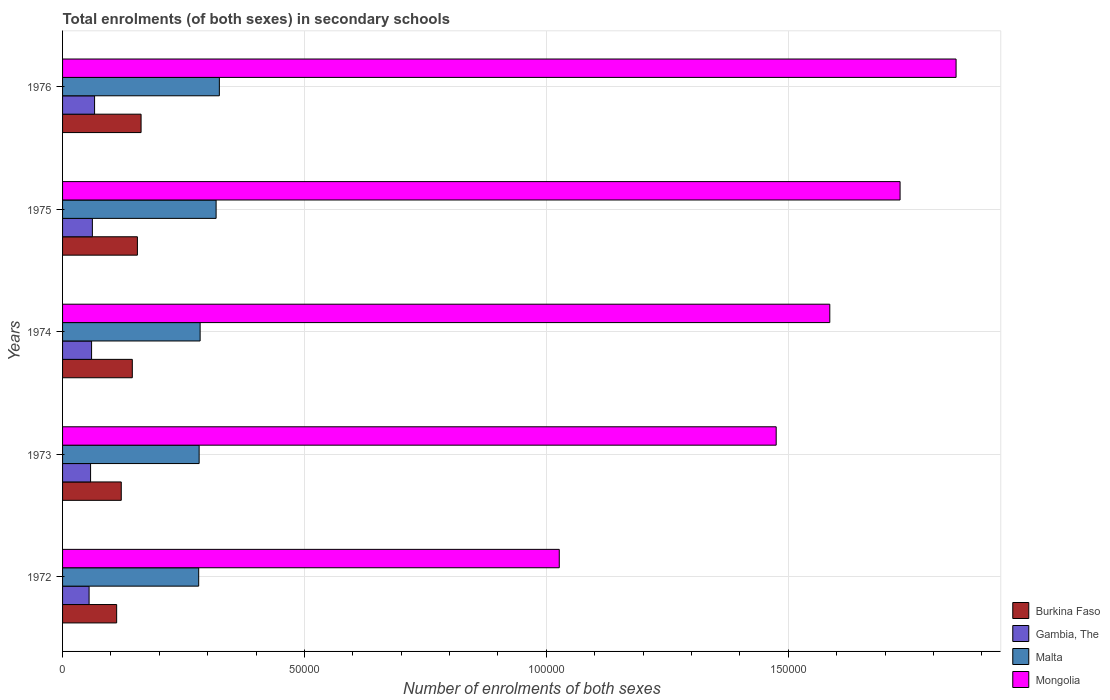How many different coloured bars are there?
Provide a succinct answer. 4. How many groups of bars are there?
Offer a very short reply. 5. Are the number of bars per tick equal to the number of legend labels?
Your answer should be very brief. Yes. How many bars are there on the 1st tick from the top?
Give a very brief answer. 4. What is the label of the 3rd group of bars from the top?
Make the answer very short. 1974. In how many cases, is the number of bars for a given year not equal to the number of legend labels?
Provide a succinct answer. 0. What is the number of enrolments in secondary schools in Malta in 1973?
Provide a succinct answer. 2.82e+04. Across all years, what is the maximum number of enrolments in secondary schools in Gambia, The?
Your response must be concise. 6618. Across all years, what is the minimum number of enrolments in secondary schools in Burkina Faso?
Offer a very short reply. 1.12e+04. In which year was the number of enrolments in secondary schools in Mongolia maximum?
Provide a succinct answer. 1976. In which year was the number of enrolments in secondary schools in Malta minimum?
Provide a succinct answer. 1972. What is the total number of enrolments in secondary schools in Malta in the graph?
Your answer should be very brief. 1.49e+05. What is the difference between the number of enrolments in secondary schools in Gambia, The in 1974 and that in 1975?
Provide a succinct answer. -165. What is the difference between the number of enrolments in secondary schools in Gambia, The in 1975 and the number of enrolments in secondary schools in Burkina Faso in 1972?
Give a very brief answer. -5017. What is the average number of enrolments in secondary schools in Gambia, The per year?
Provide a succinct answer. 6010. In the year 1973, what is the difference between the number of enrolments in secondary schools in Malta and number of enrolments in secondary schools in Mongolia?
Offer a very short reply. -1.19e+05. In how many years, is the number of enrolments in secondary schools in Mongolia greater than 170000 ?
Your response must be concise. 2. What is the ratio of the number of enrolments in secondary schools in Malta in 1972 to that in 1975?
Make the answer very short. 0.89. Is the difference between the number of enrolments in secondary schools in Malta in 1972 and 1973 greater than the difference between the number of enrolments in secondary schools in Mongolia in 1972 and 1973?
Ensure brevity in your answer.  Yes. What is the difference between the highest and the second highest number of enrolments in secondary schools in Malta?
Your answer should be very brief. 673. What is the difference between the highest and the lowest number of enrolments in secondary schools in Burkina Faso?
Ensure brevity in your answer.  5048. In how many years, is the number of enrolments in secondary schools in Burkina Faso greater than the average number of enrolments in secondary schools in Burkina Faso taken over all years?
Provide a succinct answer. 3. What does the 2nd bar from the top in 1973 represents?
Offer a terse response. Malta. What does the 2nd bar from the bottom in 1973 represents?
Provide a succinct answer. Gambia, The. How many bars are there?
Your answer should be very brief. 20. Are all the bars in the graph horizontal?
Your answer should be very brief. Yes. Are the values on the major ticks of X-axis written in scientific E-notation?
Offer a terse response. No. Does the graph contain any zero values?
Make the answer very short. No. How many legend labels are there?
Provide a short and direct response. 4. How are the legend labels stacked?
Give a very brief answer. Vertical. What is the title of the graph?
Offer a very short reply. Total enrolments (of both sexes) in secondary schools. Does "Solomon Islands" appear as one of the legend labels in the graph?
Offer a very short reply. No. What is the label or title of the X-axis?
Provide a short and direct response. Number of enrolments of both sexes. What is the label or title of the Y-axis?
Make the answer very short. Years. What is the Number of enrolments of both sexes of Burkina Faso in 1972?
Offer a very short reply. 1.12e+04. What is the Number of enrolments of both sexes in Gambia, The in 1972?
Give a very brief answer. 5482. What is the Number of enrolments of both sexes of Malta in 1972?
Keep it short and to the point. 2.81e+04. What is the Number of enrolments of both sexes of Mongolia in 1972?
Provide a succinct answer. 1.03e+05. What is the Number of enrolments of both sexes of Burkina Faso in 1973?
Offer a very short reply. 1.21e+04. What is the Number of enrolments of both sexes in Gambia, The in 1973?
Provide a succinct answer. 5791. What is the Number of enrolments of both sexes in Malta in 1973?
Your answer should be compact. 2.82e+04. What is the Number of enrolments of both sexes in Mongolia in 1973?
Your answer should be compact. 1.48e+05. What is the Number of enrolments of both sexes of Burkina Faso in 1974?
Keep it short and to the point. 1.44e+04. What is the Number of enrolments of both sexes in Gambia, The in 1974?
Keep it short and to the point. 5997. What is the Number of enrolments of both sexes in Malta in 1974?
Offer a very short reply. 2.84e+04. What is the Number of enrolments of both sexes of Mongolia in 1974?
Your answer should be very brief. 1.59e+05. What is the Number of enrolments of both sexes of Burkina Faso in 1975?
Provide a short and direct response. 1.55e+04. What is the Number of enrolments of both sexes in Gambia, The in 1975?
Your answer should be very brief. 6162. What is the Number of enrolments of both sexes of Malta in 1975?
Keep it short and to the point. 3.17e+04. What is the Number of enrolments of both sexes of Mongolia in 1975?
Your answer should be compact. 1.73e+05. What is the Number of enrolments of both sexes of Burkina Faso in 1976?
Provide a short and direct response. 1.62e+04. What is the Number of enrolments of both sexes in Gambia, The in 1976?
Make the answer very short. 6618. What is the Number of enrolments of both sexes of Malta in 1976?
Give a very brief answer. 3.24e+04. What is the Number of enrolments of both sexes of Mongolia in 1976?
Offer a terse response. 1.85e+05. Across all years, what is the maximum Number of enrolments of both sexes of Burkina Faso?
Your response must be concise. 1.62e+04. Across all years, what is the maximum Number of enrolments of both sexes of Gambia, The?
Your response must be concise. 6618. Across all years, what is the maximum Number of enrolments of both sexes of Malta?
Ensure brevity in your answer.  3.24e+04. Across all years, what is the maximum Number of enrolments of both sexes of Mongolia?
Keep it short and to the point. 1.85e+05. Across all years, what is the minimum Number of enrolments of both sexes of Burkina Faso?
Offer a very short reply. 1.12e+04. Across all years, what is the minimum Number of enrolments of both sexes in Gambia, The?
Ensure brevity in your answer.  5482. Across all years, what is the minimum Number of enrolments of both sexes of Malta?
Provide a succinct answer. 2.81e+04. Across all years, what is the minimum Number of enrolments of both sexes of Mongolia?
Your answer should be very brief. 1.03e+05. What is the total Number of enrolments of both sexes of Burkina Faso in the graph?
Provide a succinct answer. 6.94e+04. What is the total Number of enrolments of both sexes of Gambia, The in the graph?
Make the answer very short. 3.00e+04. What is the total Number of enrolments of both sexes in Malta in the graph?
Your answer should be compact. 1.49e+05. What is the total Number of enrolments of both sexes of Mongolia in the graph?
Provide a succinct answer. 7.67e+05. What is the difference between the Number of enrolments of both sexes of Burkina Faso in 1972 and that in 1973?
Your answer should be very brief. -953. What is the difference between the Number of enrolments of both sexes of Gambia, The in 1972 and that in 1973?
Keep it short and to the point. -309. What is the difference between the Number of enrolments of both sexes in Malta in 1972 and that in 1973?
Ensure brevity in your answer.  -94. What is the difference between the Number of enrolments of both sexes of Mongolia in 1972 and that in 1973?
Provide a succinct answer. -4.48e+04. What is the difference between the Number of enrolments of both sexes in Burkina Faso in 1972 and that in 1974?
Give a very brief answer. -3237. What is the difference between the Number of enrolments of both sexes in Gambia, The in 1972 and that in 1974?
Provide a short and direct response. -515. What is the difference between the Number of enrolments of both sexes of Malta in 1972 and that in 1974?
Offer a terse response. -297. What is the difference between the Number of enrolments of both sexes of Mongolia in 1972 and that in 1974?
Ensure brevity in your answer.  -5.59e+04. What is the difference between the Number of enrolments of both sexes in Burkina Faso in 1972 and that in 1975?
Offer a terse response. -4291. What is the difference between the Number of enrolments of both sexes in Gambia, The in 1972 and that in 1975?
Ensure brevity in your answer.  -680. What is the difference between the Number of enrolments of both sexes in Malta in 1972 and that in 1975?
Make the answer very short. -3599. What is the difference between the Number of enrolments of both sexes in Mongolia in 1972 and that in 1975?
Keep it short and to the point. -7.04e+04. What is the difference between the Number of enrolments of both sexes of Burkina Faso in 1972 and that in 1976?
Provide a short and direct response. -5048. What is the difference between the Number of enrolments of both sexes of Gambia, The in 1972 and that in 1976?
Keep it short and to the point. -1136. What is the difference between the Number of enrolments of both sexes in Malta in 1972 and that in 1976?
Provide a succinct answer. -4272. What is the difference between the Number of enrolments of both sexes in Mongolia in 1972 and that in 1976?
Your answer should be compact. -8.20e+04. What is the difference between the Number of enrolments of both sexes in Burkina Faso in 1973 and that in 1974?
Offer a very short reply. -2284. What is the difference between the Number of enrolments of both sexes in Gambia, The in 1973 and that in 1974?
Provide a short and direct response. -206. What is the difference between the Number of enrolments of both sexes of Malta in 1973 and that in 1974?
Your answer should be very brief. -203. What is the difference between the Number of enrolments of both sexes of Mongolia in 1973 and that in 1974?
Make the answer very short. -1.11e+04. What is the difference between the Number of enrolments of both sexes in Burkina Faso in 1973 and that in 1975?
Your answer should be very brief. -3338. What is the difference between the Number of enrolments of both sexes of Gambia, The in 1973 and that in 1975?
Provide a short and direct response. -371. What is the difference between the Number of enrolments of both sexes of Malta in 1973 and that in 1975?
Offer a terse response. -3505. What is the difference between the Number of enrolments of both sexes of Mongolia in 1973 and that in 1975?
Make the answer very short. -2.56e+04. What is the difference between the Number of enrolments of both sexes in Burkina Faso in 1973 and that in 1976?
Give a very brief answer. -4095. What is the difference between the Number of enrolments of both sexes of Gambia, The in 1973 and that in 1976?
Offer a very short reply. -827. What is the difference between the Number of enrolments of both sexes in Malta in 1973 and that in 1976?
Your answer should be compact. -4178. What is the difference between the Number of enrolments of both sexes in Mongolia in 1973 and that in 1976?
Your answer should be very brief. -3.72e+04. What is the difference between the Number of enrolments of both sexes in Burkina Faso in 1974 and that in 1975?
Keep it short and to the point. -1054. What is the difference between the Number of enrolments of both sexes in Gambia, The in 1974 and that in 1975?
Your answer should be very brief. -165. What is the difference between the Number of enrolments of both sexes of Malta in 1974 and that in 1975?
Make the answer very short. -3302. What is the difference between the Number of enrolments of both sexes in Mongolia in 1974 and that in 1975?
Your answer should be very brief. -1.45e+04. What is the difference between the Number of enrolments of both sexes in Burkina Faso in 1974 and that in 1976?
Provide a short and direct response. -1811. What is the difference between the Number of enrolments of both sexes of Gambia, The in 1974 and that in 1976?
Your answer should be compact. -621. What is the difference between the Number of enrolments of both sexes of Malta in 1974 and that in 1976?
Give a very brief answer. -3975. What is the difference between the Number of enrolments of both sexes in Mongolia in 1974 and that in 1976?
Offer a terse response. -2.61e+04. What is the difference between the Number of enrolments of both sexes of Burkina Faso in 1975 and that in 1976?
Your response must be concise. -757. What is the difference between the Number of enrolments of both sexes in Gambia, The in 1975 and that in 1976?
Offer a very short reply. -456. What is the difference between the Number of enrolments of both sexes in Malta in 1975 and that in 1976?
Provide a short and direct response. -673. What is the difference between the Number of enrolments of both sexes in Mongolia in 1975 and that in 1976?
Provide a succinct answer. -1.16e+04. What is the difference between the Number of enrolments of both sexes in Burkina Faso in 1972 and the Number of enrolments of both sexes in Gambia, The in 1973?
Give a very brief answer. 5388. What is the difference between the Number of enrolments of both sexes in Burkina Faso in 1972 and the Number of enrolments of both sexes in Malta in 1973?
Provide a short and direct response. -1.71e+04. What is the difference between the Number of enrolments of both sexes of Burkina Faso in 1972 and the Number of enrolments of both sexes of Mongolia in 1973?
Make the answer very short. -1.36e+05. What is the difference between the Number of enrolments of both sexes of Gambia, The in 1972 and the Number of enrolments of both sexes of Malta in 1973?
Offer a very short reply. -2.27e+04. What is the difference between the Number of enrolments of both sexes in Gambia, The in 1972 and the Number of enrolments of both sexes in Mongolia in 1973?
Your answer should be compact. -1.42e+05. What is the difference between the Number of enrolments of both sexes in Malta in 1972 and the Number of enrolments of both sexes in Mongolia in 1973?
Keep it short and to the point. -1.19e+05. What is the difference between the Number of enrolments of both sexes in Burkina Faso in 1972 and the Number of enrolments of both sexes in Gambia, The in 1974?
Your response must be concise. 5182. What is the difference between the Number of enrolments of both sexes in Burkina Faso in 1972 and the Number of enrolments of both sexes in Malta in 1974?
Offer a terse response. -1.73e+04. What is the difference between the Number of enrolments of both sexes of Burkina Faso in 1972 and the Number of enrolments of both sexes of Mongolia in 1974?
Keep it short and to the point. -1.47e+05. What is the difference between the Number of enrolments of both sexes of Gambia, The in 1972 and the Number of enrolments of both sexes of Malta in 1974?
Offer a terse response. -2.30e+04. What is the difference between the Number of enrolments of both sexes in Gambia, The in 1972 and the Number of enrolments of both sexes in Mongolia in 1974?
Provide a short and direct response. -1.53e+05. What is the difference between the Number of enrolments of both sexes in Malta in 1972 and the Number of enrolments of both sexes in Mongolia in 1974?
Your answer should be compact. -1.30e+05. What is the difference between the Number of enrolments of both sexes in Burkina Faso in 1972 and the Number of enrolments of both sexes in Gambia, The in 1975?
Your answer should be very brief. 5017. What is the difference between the Number of enrolments of both sexes of Burkina Faso in 1972 and the Number of enrolments of both sexes of Malta in 1975?
Make the answer very short. -2.06e+04. What is the difference between the Number of enrolments of both sexes in Burkina Faso in 1972 and the Number of enrolments of both sexes in Mongolia in 1975?
Ensure brevity in your answer.  -1.62e+05. What is the difference between the Number of enrolments of both sexes in Gambia, The in 1972 and the Number of enrolments of both sexes in Malta in 1975?
Your answer should be very brief. -2.63e+04. What is the difference between the Number of enrolments of both sexes in Gambia, The in 1972 and the Number of enrolments of both sexes in Mongolia in 1975?
Make the answer very short. -1.68e+05. What is the difference between the Number of enrolments of both sexes of Malta in 1972 and the Number of enrolments of both sexes of Mongolia in 1975?
Your answer should be compact. -1.45e+05. What is the difference between the Number of enrolments of both sexes in Burkina Faso in 1972 and the Number of enrolments of both sexes in Gambia, The in 1976?
Keep it short and to the point. 4561. What is the difference between the Number of enrolments of both sexes in Burkina Faso in 1972 and the Number of enrolments of both sexes in Malta in 1976?
Keep it short and to the point. -2.12e+04. What is the difference between the Number of enrolments of both sexes of Burkina Faso in 1972 and the Number of enrolments of both sexes of Mongolia in 1976?
Keep it short and to the point. -1.74e+05. What is the difference between the Number of enrolments of both sexes of Gambia, The in 1972 and the Number of enrolments of both sexes of Malta in 1976?
Provide a succinct answer. -2.69e+04. What is the difference between the Number of enrolments of both sexes in Gambia, The in 1972 and the Number of enrolments of both sexes in Mongolia in 1976?
Give a very brief answer. -1.79e+05. What is the difference between the Number of enrolments of both sexes in Malta in 1972 and the Number of enrolments of both sexes in Mongolia in 1976?
Provide a short and direct response. -1.57e+05. What is the difference between the Number of enrolments of both sexes of Burkina Faso in 1973 and the Number of enrolments of both sexes of Gambia, The in 1974?
Give a very brief answer. 6135. What is the difference between the Number of enrolments of both sexes of Burkina Faso in 1973 and the Number of enrolments of both sexes of Malta in 1974?
Give a very brief answer. -1.63e+04. What is the difference between the Number of enrolments of both sexes of Burkina Faso in 1973 and the Number of enrolments of both sexes of Mongolia in 1974?
Offer a terse response. -1.46e+05. What is the difference between the Number of enrolments of both sexes of Gambia, The in 1973 and the Number of enrolments of both sexes of Malta in 1974?
Give a very brief answer. -2.26e+04. What is the difference between the Number of enrolments of both sexes in Gambia, The in 1973 and the Number of enrolments of both sexes in Mongolia in 1974?
Keep it short and to the point. -1.53e+05. What is the difference between the Number of enrolments of both sexes of Malta in 1973 and the Number of enrolments of both sexes of Mongolia in 1974?
Provide a short and direct response. -1.30e+05. What is the difference between the Number of enrolments of both sexes in Burkina Faso in 1973 and the Number of enrolments of both sexes in Gambia, The in 1975?
Your answer should be very brief. 5970. What is the difference between the Number of enrolments of both sexes of Burkina Faso in 1973 and the Number of enrolments of both sexes of Malta in 1975?
Provide a short and direct response. -1.96e+04. What is the difference between the Number of enrolments of both sexes in Burkina Faso in 1973 and the Number of enrolments of both sexes in Mongolia in 1975?
Your answer should be compact. -1.61e+05. What is the difference between the Number of enrolments of both sexes in Gambia, The in 1973 and the Number of enrolments of both sexes in Malta in 1975?
Ensure brevity in your answer.  -2.59e+04. What is the difference between the Number of enrolments of both sexes in Gambia, The in 1973 and the Number of enrolments of both sexes in Mongolia in 1975?
Give a very brief answer. -1.67e+05. What is the difference between the Number of enrolments of both sexes in Malta in 1973 and the Number of enrolments of both sexes in Mongolia in 1975?
Make the answer very short. -1.45e+05. What is the difference between the Number of enrolments of both sexes in Burkina Faso in 1973 and the Number of enrolments of both sexes in Gambia, The in 1976?
Keep it short and to the point. 5514. What is the difference between the Number of enrolments of both sexes of Burkina Faso in 1973 and the Number of enrolments of both sexes of Malta in 1976?
Your answer should be very brief. -2.03e+04. What is the difference between the Number of enrolments of both sexes of Burkina Faso in 1973 and the Number of enrolments of both sexes of Mongolia in 1976?
Keep it short and to the point. -1.73e+05. What is the difference between the Number of enrolments of both sexes of Gambia, The in 1973 and the Number of enrolments of both sexes of Malta in 1976?
Make the answer very short. -2.66e+04. What is the difference between the Number of enrolments of both sexes of Gambia, The in 1973 and the Number of enrolments of both sexes of Mongolia in 1976?
Your answer should be compact. -1.79e+05. What is the difference between the Number of enrolments of both sexes of Malta in 1973 and the Number of enrolments of both sexes of Mongolia in 1976?
Keep it short and to the point. -1.56e+05. What is the difference between the Number of enrolments of both sexes of Burkina Faso in 1974 and the Number of enrolments of both sexes of Gambia, The in 1975?
Provide a short and direct response. 8254. What is the difference between the Number of enrolments of both sexes of Burkina Faso in 1974 and the Number of enrolments of both sexes of Malta in 1975?
Ensure brevity in your answer.  -1.73e+04. What is the difference between the Number of enrolments of both sexes in Burkina Faso in 1974 and the Number of enrolments of both sexes in Mongolia in 1975?
Provide a succinct answer. -1.59e+05. What is the difference between the Number of enrolments of both sexes of Gambia, The in 1974 and the Number of enrolments of both sexes of Malta in 1975?
Offer a terse response. -2.57e+04. What is the difference between the Number of enrolments of both sexes of Gambia, The in 1974 and the Number of enrolments of both sexes of Mongolia in 1975?
Provide a short and direct response. -1.67e+05. What is the difference between the Number of enrolments of both sexes in Malta in 1974 and the Number of enrolments of both sexes in Mongolia in 1975?
Provide a succinct answer. -1.45e+05. What is the difference between the Number of enrolments of both sexes of Burkina Faso in 1974 and the Number of enrolments of both sexes of Gambia, The in 1976?
Offer a very short reply. 7798. What is the difference between the Number of enrolments of both sexes of Burkina Faso in 1974 and the Number of enrolments of both sexes of Malta in 1976?
Your answer should be very brief. -1.80e+04. What is the difference between the Number of enrolments of both sexes in Burkina Faso in 1974 and the Number of enrolments of both sexes in Mongolia in 1976?
Provide a short and direct response. -1.70e+05. What is the difference between the Number of enrolments of both sexes in Gambia, The in 1974 and the Number of enrolments of both sexes in Malta in 1976?
Your answer should be compact. -2.64e+04. What is the difference between the Number of enrolments of both sexes in Gambia, The in 1974 and the Number of enrolments of both sexes in Mongolia in 1976?
Your answer should be compact. -1.79e+05. What is the difference between the Number of enrolments of both sexes in Malta in 1974 and the Number of enrolments of both sexes in Mongolia in 1976?
Provide a short and direct response. -1.56e+05. What is the difference between the Number of enrolments of both sexes of Burkina Faso in 1975 and the Number of enrolments of both sexes of Gambia, The in 1976?
Ensure brevity in your answer.  8852. What is the difference between the Number of enrolments of both sexes in Burkina Faso in 1975 and the Number of enrolments of both sexes in Malta in 1976?
Ensure brevity in your answer.  -1.69e+04. What is the difference between the Number of enrolments of both sexes of Burkina Faso in 1975 and the Number of enrolments of both sexes of Mongolia in 1976?
Your answer should be very brief. -1.69e+05. What is the difference between the Number of enrolments of both sexes of Gambia, The in 1975 and the Number of enrolments of both sexes of Malta in 1976?
Your answer should be very brief. -2.62e+04. What is the difference between the Number of enrolments of both sexes of Gambia, The in 1975 and the Number of enrolments of both sexes of Mongolia in 1976?
Ensure brevity in your answer.  -1.79e+05. What is the difference between the Number of enrolments of both sexes in Malta in 1975 and the Number of enrolments of both sexes in Mongolia in 1976?
Your answer should be very brief. -1.53e+05. What is the average Number of enrolments of both sexes in Burkina Faso per year?
Offer a very short reply. 1.39e+04. What is the average Number of enrolments of both sexes in Gambia, The per year?
Offer a very short reply. 6010. What is the average Number of enrolments of both sexes of Malta per year?
Keep it short and to the point. 2.98e+04. What is the average Number of enrolments of both sexes in Mongolia per year?
Your response must be concise. 1.53e+05. In the year 1972, what is the difference between the Number of enrolments of both sexes in Burkina Faso and Number of enrolments of both sexes in Gambia, The?
Keep it short and to the point. 5697. In the year 1972, what is the difference between the Number of enrolments of both sexes of Burkina Faso and Number of enrolments of both sexes of Malta?
Offer a terse response. -1.70e+04. In the year 1972, what is the difference between the Number of enrolments of both sexes in Burkina Faso and Number of enrolments of both sexes in Mongolia?
Your response must be concise. -9.15e+04. In the year 1972, what is the difference between the Number of enrolments of both sexes of Gambia, The and Number of enrolments of both sexes of Malta?
Provide a short and direct response. -2.27e+04. In the year 1972, what is the difference between the Number of enrolments of both sexes in Gambia, The and Number of enrolments of both sexes in Mongolia?
Keep it short and to the point. -9.72e+04. In the year 1972, what is the difference between the Number of enrolments of both sexes in Malta and Number of enrolments of both sexes in Mongolia?
Provide a succinct answer. -7.45e+04. In the year 1973, what is the difference between the Number of enrolments of both sexes of Burkina Faso and Number of enrolments of both sexes of Gambia, The?
Provide a succinct answer. 6341. In the year 1973, what is the difference between the Number of enrolments of both sexes of Burkina Faso and Number of enrolments of both sexes of Malta?
Give a very brief answer. -1.61e+04. In the year 1973, what is the difference between the Number of enrolments of both sexes in Burkina Faso and Number of enrolments of both sexes in Mongolia?
Offer a terse response. -1.35e+05. In the year 1973, what is the difference between the Number of enrolments of both sexes of Gambia, The and Number of enrolments of both sexes of Malta?
Provide a succinct answer. -2.24e+04. In the year 1973, what is the difference between the Number of enrolments of both sexes in Gambia, The and Number of enrolments of both sexes in Mongolia?
Ensure brevity in your answer.  -1.42e+05. In the year 1973, what is the difference between the Number of enrolments of both sexes of Malta and Number of enrolments of both sexes of Mongolia?
Provide a succinct answer. -1.19e+05. In the year 1974, what is the difference between the Number of enrolments of both sexes of Burkina Faso and Number of enrolments of both sexes of Gambia, The?
Ensure brevity in your answer.  8419. In the year 1974, what is the difference between the Number of enrolments of both sexes of Burkina Faso and Number of enrolments of both sexes of Malta?
Keep it short and to the point. -1.40e+04. In the year 1974, what is the difference between the Number of enrolments of both sexes of Burkina Faso and Number of enrolments of both sexes of Mongolia?
Your answer should be very brief. -1.44e+05. In the year 1974, what is the difference between the Number of enrolments of both sexes of Gambia, The and Number of enrolments of both sexes of Malta?
Make the answer very short. -2.24e+04. In the year 1974, what is the difference between the Number of enrolments of both sexes in Gambia, The and Number of enrolments of both sexes in Mongolia?
Offer a terse response. -1.53e+05. In the year 1974, what is the difference between the Number of enrolments of both sexes of Malta and Number of enrolments of both sexes of Mongolia?
Offer a very short reply. -1.30e+05. In the year 1975, what is the difference between the Number of enrolments of both sexes of Burkina Faso and Number of enrolments of both sexes of Gambia, The?
Provide a short and direct response. 9308. In the year 1975, what is the difference between the Number of enrolments of both sexes of Burkina Faso and Number of enrolments of both sexes of Malta?
Offer a very short reply. -1.63e+04. In the year 1975, what is the difference between the Number of enrolments of both sexes of Burkina Faso and Number of enrolments of both sexes of Mongolia?
Offer a terse response. -1.58e+05. In the year 1975, what is the difference between the Number of enrolments of both sexes of Gambia, The and Number of enrolments of both sexes of Malta?
Make the answer very short. -2.56e+04. In the year 1975, what is the difference between the Number of enrolments of both sexes of Gambia, The and Number of enrolments of both sexes of Mongolia?
Keep it short and to the point. -1.67e+05. In the year 1975, what is the difference between the Number of enrolments of both sexes of Malta and Number of enrolments of both sexes of Mongolia?
Your answer should be very brief. -1.41e+05. In the year 1976, what is the difference between the Number of enrolments of both sexes in Burkina Faso and Number of enrolments of both sexes in Gambia, The?
Your answer should be very brief. 9609. In the year 1976, what is the difference between the Number of enrolments of both sexes in Burkina Faso and Number of enrolments of both sexes in Malta?
Give a very brief answer. -1.62e+04. In the year 1976, what is the difference between the Number of enrolments of both sexes of Burkina Faso and Number of enrolments of both sexes of Mongolia?
Your response must be concise. -1.68e+05. In the year 1976, what is the difference between the Number of enrolments of both sexes of Gambia, The and Number of enrolments of both sexes of Malta?
Make the answer very short. -2.58e+04. In the year 1976, what is the difference between the Number of enrolments of both sexes in Gambia, The and Number of enrolments of both sexes in Mongolia?
Your answer should be compact. -1.78e+05. In the year 1976, what is the difference between the Number of enrolments of both sexes in Malta and Number of enrolments of both sexes in Mongolia?
Keep it short and to the point. -1.52e+05. What is the ratio of the Number of enrolments of both sexes in Burkina Faso in 1972 to that in 1973?
Offer a very short reply. 0.92. What is the ratio of the Number of enrolments of both sexes of Gambia, The in 1972 to that in 1973?
Your response must be concise. 0.95. What is the ratio of the Number of enrolments of both sexes of Malta in 1972 to that in 1973?
Ensure brevity in your answer.  1. What is the ratio of the Number of enrolments of both sexes in Mongolia in 1972 to that in 1973?
Your answer should be very brief. 0.7. What is the ratio of the Number of enrolments of both sexes of Burkina Faso in 1972 to that in 1974?
Offer a terse response. 0.78. What is the ratio of the Number of enrolments of both sexes of Gambia, The in 1972 to that in 1974?
Keep it short and to the point. 0.91. What is the ratio of the Number of enrolments of both sexes of Malta in 1972 to that in 1974?
Keep it short and to the point. 0.99. What is the ratio of the Number of enrolments of both sexes in Mongolia in 1972 to that in 1974?
Keep it short and to the point. 0.65. What is the ratio of the Number of enrolments of both sexes in Burkina Faso in 1972 to that in 1975?
Your response must be concise. 0.72. What is the ratio of the Number of enrolments of both sexes of Gambia, The in 1972 to that in 1975?
Provide a succinct answer. 0.89. What is the ratio of the Number of enrolments of both sexes in Malta in 1972 to that in 1975?
Make the answer very short. 0.89. What is the ratio of the Number of enrolments of both sexes in Mongolia in 1972 to that in 1975?
Offer a very short reply. 0.59. What is the ratio of the Number of enrolments of both sexes in Burkina Faso in 1972 to that in 1976?
Offer a terse response. 0.69. What is the ratio of the Number of enrolments of both sexes in Gambia, The in 1972 to that in 1976?
Provide a succinct answer. 0.83. What is the ratio of the Number of enrolments of both sexes of Malta in 1972 to that in 1976?
Keep it short and to the point. 0.87. What is the ratio of the Number of enrolments of both sexes of Mongolia in 1972 to that in 1976?
Offer a very short reply. 0.56. What is the ratio of the Number of enrolments of both sexes in Burkina Faso in 1973 to that in 1974?
Your response must be concise. 0.84. What is the ratio of the Number of enrolments of both sexes of Gambia, The in 1973 to that in 1974?
Offer a terse response. 0.97. What is the ratio of the Number of enrolments of both sexes in Mongolia in 1973 to that in 1974?
Make the answer very short. 0.93. What is the ratio of the Number of enrolments of both sexes of Burkina Faso in 1973 to that in 1975?
Your response must be concise. 0.78. What is the ratio of the Number of enrolments of both sexes of Gambia, The in 1973 to that in 1975?
Your answer should be compact. 0.94. What is the ratio of the Number of enrolments of both sexes of Malta in 1973 to that in 1975?
Offer a terse response. 0.89. What is the ratio of the Number of enrolments of both sexes in Mongolia in 1973 to that in 1975?
Ensure brevity in your answer.  0.85. What is the ratio of the Number of enrolments of both sexes in Burkina Faso in 1973 to that in 1976?
Your answer should be very brief. 0.75. What is the ratio of the Number of enrolments of both sexes of Gambia, The in 1973 to that in 1976?
Your answer should be compact. 0.88. What is the ratio of the Number of enrolments of both sexes in Malta in 1973 to that in 1976?
Offer a very short reply. 0.87. What is the ratio of the Number of enrolments of both sexes of Mongolia in 1973 to that in 1976?
Ensure brevity in your answer.  0.8. What is the ratio of the Number of enrolments of both sexes of Burkina Faso in 1974 to that in 1975?
Offer a terse response. 0.93. What is the ratio of the Number of enrolments of both sexes in Gambia, The in 1974 to that in 1975?
Provide a short and direct response. 0.97. What is the ratio of the Number of enrolments of both sexes in Malta in 1974 to that in 1975?
Provide a succinct answer. 0.9. What is the ratio of the Number of enrolments of both sexes in Mongolia in 1974 to that in 1975?
Keep it short and to the point. 0.92. What is the ratio of the Number of enrolments of both sexes in Burkina Faso in 1974 to that in 1976?
Offer a very short reply. 0.89. What is the ratio of the Number of enrolments of both sexes in Gambia, The in 1974 to that in 1976?
Provide a short and direct response. 0.91. What is the ratio of the Number of enrolments of both sexes of Malta in 1974 to that in 1976?
Your response must be concise. 0.88. What is the ratio of the Number of enrolments of both sexes in Mongolia in 1974 to that in 1976?
Your answer should be very brief. 0.86. What is the ratio of the Number of enrolments of both sexes in Burkina Faso in 1975 to that in 1976?
Ensure brevity in your answer.  0.95. What is the ratio of the Number of enrolments of both sexes in Gambia, The in 1975 to that in 1976?
Ensure brevity in your answer.  0.93. What is the ratio of the Number of enrolments of both sexes in Malta in 1975 to that in 1976?
Provide a succinct answer. 0.98. What is the ratio of the Number of enrolments of both sexes in Mongolia in 1975 to that in 1976?
Offer a very short reply. 0.94. What is the difference between the highest and the second highest Number of enrolments of both sexes in Burkina Faso?
Offer a terse response. 757. What is the difference between the highest and the second highest Number of enrolments of both sexes of Gambia, The?
Provide a short and direct response. 456. What is the difference between the highest and the second highest Number of enrolments of both sexes in Malta?
Your answer should be compact. 673. What is the difference between the highest and the second highest Number of enrolments of both sexes of Mongolia?
Ensure brevity in your answer.  1.16e+04. What is the difference between the highest and the lowest Number of enrolments of both sexes of Burkina Faso?
Ensure brevity in your answer.  5048. What is the difference between the highest and the lowest Number of enrolments of both sexes of Gambia, The?
Make the answer very short. 1136. What is the difference between the highest and the lowest Number of enrolments of both sexes in Malta?
Your answer should be compact. 4272. What is the difference between the highest and the lowest Number of enrolments of both sexes of Mongolia?
Give a very brief answer. 8.20e+04. 